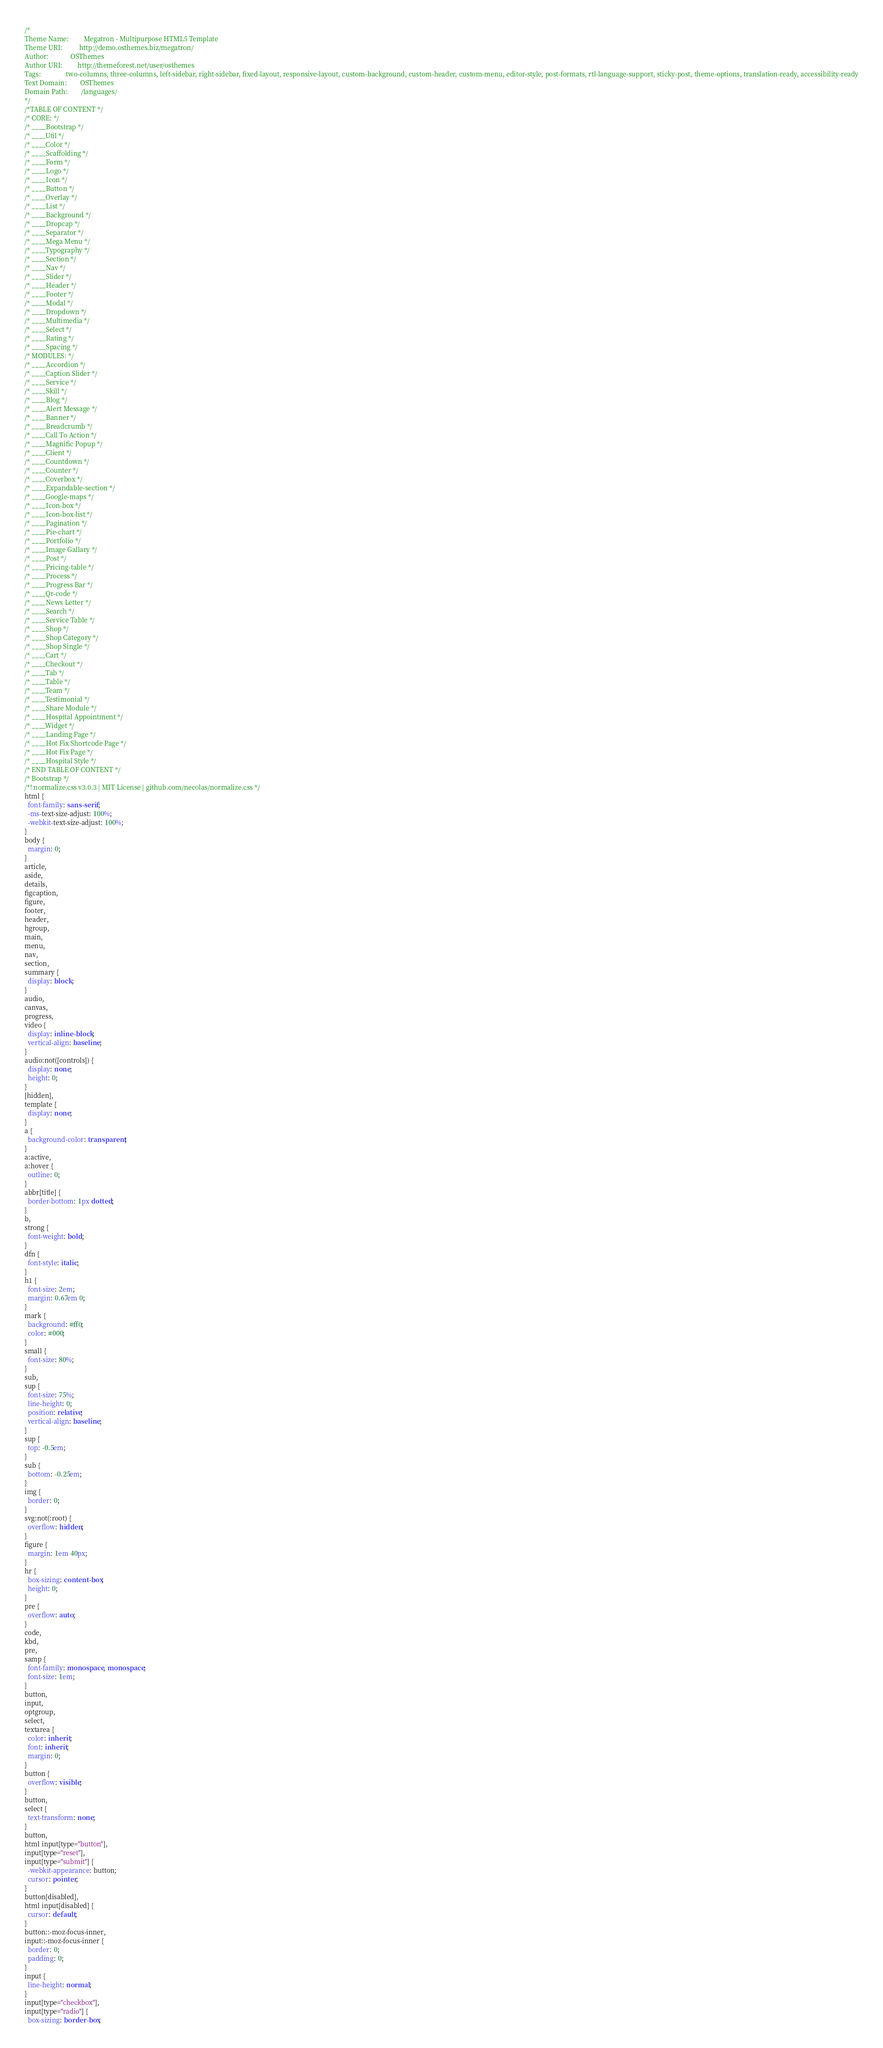<code> <loc_0><loc_0><loc_500><loc_500><_CSS_>/*
Theme Name:         Megatron - Multipurpose HTML5 Template
Theme URI:          http://demo.osthemes.biz/megatron/
Author:             OSThemes
Author URI:         http://themeforest.net/user/osthemes
Tags: 				two-columns, three-columns, left-sidebar, right-sidebar, fixed-layout, responsive-layout, custom-background, custom-header, custom-menu, editor-style, post-formats, rtl-language-support, sticky-post, theme-options, translation-ready, accessibility-ready
Text Domain: 		OSThemes
Domain Path: 		/languages/
*/
/*TABLE OF CONTENT */
/* CORE: */
/* ____Bootstrap */
/* ____Util */
/* ____Color */
/* ____Scaffolding */
/* ____Form */
/* ____Logo */
/* ____Icon */
/* ____Button */
/* ____Overlay */
/* ____List */
/* ____Background */
/* ____Dropcap */
/* ____Separator */
/* ____Mega Menu */
/* ____Typography */
/* ____Section */
/* ____Nav */
/* ____Slider */
/* ____Header */
/* ____Footer */
/* ____Modal */
/* ____Dropdown */
/* ____Multimedia */
/* ____Select */
/* ____Rating */
/* ____Spacing */
/* MODULES: */
/* ____Accordion */
/* ____Caption Slider */
/* ____Service */
/* ____Skill */
/* ____Blog */
/* ____Alert Message */
/* ____Banner */
/* ____Breadcrumb */
/* ____Call To Action */
/* ____Magnific Popup */
/* ____Client */
/* ____Countdown */
/* ____Counter */
/* ____Coverbox */
/* ____Expandable-section */
/* ____Google-maps */
/* ____Icon-box */
/* ____Icon-box-list */
/* ____Pagination */
/* ____Pie-chart */
/* ____Portfolio */
/* ____Image Gallary */
/* ____Post */
/* ____Pricing-table */
/* ____Process */
/* ____Progress Bar */
/* ____Qr-code */
/* ____News Letter */
/* ____Search */
/* ____Service Table */
/* ____Shop */
/* ____Shop Category */
/* ____Shop Single */
/* ____Cart */
/* ____Checkout */
/* ____Tab */
/* ____Table */
/* ____Team */
/* ____Testimonial */
/* ____Share Module */
/* ____Hospital Appointment */
/* ____Widget */
/* ____Landing Page */
/* ____Hot Fix Shortcode Page */
/* ____Hot Fix Page */
/* ____Hospital Style */
/* END TABLE OF CONTENT */
/* Bootstrap */
/*! normalize.css v3.0.3 | MIT License | github.com/necolas/normalize.css */
html {
  font-family: sans-serif;
  -ms-text-size-adjust: 100%;
  -webkit-text-size-adjust: 100%;
}
body {
  margin: 0;
}
article,
aside,
details,
figcaption,
figure,
footer,
header,
hgroup,
main,
menu,
nav,
section,
summary {
  display: block;
}
audio,
canvas,
progress,
video {
  display: inline-block;
  vertical-align: baseline;
}
audio:not([controls]) {
  display: none;
  height: 0;
}
[hidden],
template {
  display: none;
}
a {
  background-color: transparent;
}
a:active,
a:hover {
  outline: 0;
}
abbr[title] {
  border-bottom: 1px dotted;
}
b,
strong {
  font-weight: bold;
}
dfn {
  font-style: italic;
}
h1 {
  font-size: 2em;
  margin: 0.67em 0;
}
mark {
  background: #ff0;
  color: #000;
}
small {
  font-size: 80%;
}
sub,
sup {
  font-size: 75%;
  line-height: 0;
  position: relative;
  vertical-align: baseline;
}
sup {
  top: -0.5em;
}
sub {
  bottom: -0.25em;
}
img {
  border: 0;
}
svg:not(:root) {
  overflow: hidden;
}
figure {
  margin: 1em 40px;
}
hr {
  box-sizing: content-box;
  height: 0;
}
pre {
  overflow: auto;
}
code,
kbd,
pre,
samp {
  font-family: monospace, monospace;
  font-size: 1em;
}
button,
input,
optgroup,
select,
textarea {
  color: inherit;
  font: inherit;
  margin: 0;
}
button {
  overflow: visible;
}
button,
select {
  text-transform: none;
}
button,
html input[type="button"],
input[type="reset"],
input[type="submit"] {
  -webkit-appearance: button;
  cursor: pointer;
}
button[disabled],
html input[disabled] {
  cursor: default;
}
button::-moz-focus-inner,
input::-moz-focus-inner {
  border: 0;
  padding: 0;
}
input {
  line-height: normal;
}
input[type="checkbox"],
input[type="radio"] {
  box-sizing: border-box;</code> 